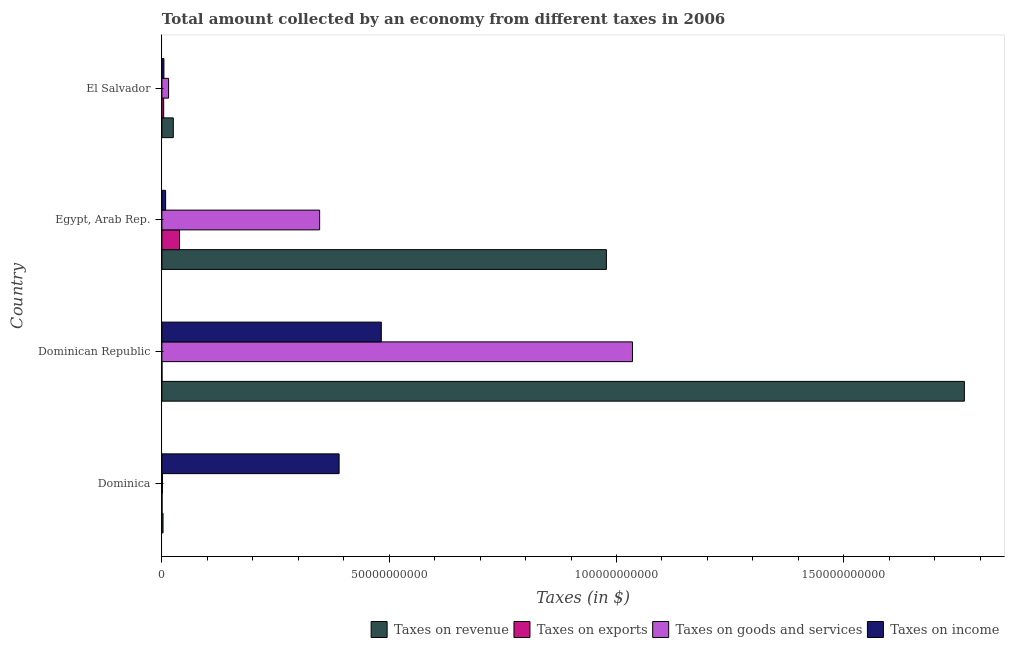How many different coloured bars are there?
Give a very brief answer. 4. How many groups of bars are there?
Offer a very short reply. 4. How many bars are there on the 4th tick from the top?
Ensure brevity in your answer.  4. What is the label of the 3rd group of bars from the top?
Provide a short and direct response. Dominican Republic. What is the amount collected as tax on revenue in Dominican Republic?
Provide a succinct answer. 1.77e+11. Across all countries, what is the maximum amount collected as tax on income?
Offer a terse response. 4.83e+1. Across all countries, what is the minimum amount collected as tax on exports?
Give a very brief answer. 7.49e+06. In which country was the amount collected as tax on exports maximum?
Make the answer very short. Egypt, Arab Rep. In which country was the amount collected as tax on goods minimum?
Give a very brief answer. Dominica. What is the total amount collected as tax on revenue in the graph?
Offer a very short reply. 2.77e+11. What is the difference between the amount collected as tax on income in Dominica and that in Egypt, Arab Rep.?
Provide a succinct answer. 3.82e+1. What is the difference between the amount collected as tax on income in Dominican Republic and the amount collected as tax on revenue in Egypt, Arab Rep.?
Your answer should be compact. -4.95e+1. What is the average amount collected as tax on goods per country?
Your response must be concise. 3.50e+1. What is the difference between the amount collected as tax on revenue and amount collected as tax on goods in Egypt, Arab Rep.?
Offer a terse response. 6.31e+1. In how many countries, is the amount collected as tax on goods greater than 160000000000 $?
Make the answer very short. 0. What is the ratio of the amount collected as tax on revenue in Dominica to that in Egypt, Arab Rep.?
Make the answer very short. 0. Is the amount collected as tax on revenue in Dominican Republic less than that in El Salvador?
Offer a very short reply. No. What is the difference between the highest and the second highest amount collected as tax on goods?
Offer a terse response. 6.88e+1. What is the difference between the highest and the lowest amount collected as tax on goods?
Give a very brief answer. 1.03e+11. In how many countries, is the amount collected as tax on revenue greater than the average amount collected as tax on revenue taken over all countries?
Offer a terse response. 2. Is the sum of the amount collected as tax on revenue in Egypt, Arab Rep. and El Salvador greater than the maximum amount collected as tax on income across all countries?
Your answer should be compact. Yes. What does the 2nd bar from the top in Egypt, Arab Rep. represents?
Your answer should be compact. Taxes on goods and services. What does the 4th bar from the bottom in Dominica represents?
Your answer should be compact. Taxes on income. How many bars are there?
Your response must be concise. 16. Are all the bars in the graph horizontal?
Your response must be concise. Yes. How many countries are there in the graph?
Ensure brevity in your answer.  4. Where does the legend appear in the graph?
Give a very brief answer. Bottom right. How many legend labels are there?
Provide a short and direct response. 4. What is the title of the graph?
Give a very brief answer. Total amount collected by an economy from different taxes in 2006. What is the label or title of the X-axis?
Keep it short and to the point. Taxes (in $). What is the Taxes (in $) of Taxes on revenue in Dominica?
Offer a terse response. 2.48e+08. What is the Taxes (in $) of Taxes on exports in Dominica?
Your answer should be compact. 2.40e+07. What is the Taxes (in $) in Taxes on goods and services in Dominica?
Offer a terse response. 1.23e+08. What is the Taxes (in $) in Taxes on income in Dominica?
Ensure brevity in your answer.  3.90e+1. What is the Taxes (in $) of Taxes on revenue in Dominican Republic?
Your response must be concise. 1.77e+11. What is the Taxes (in $) in Taxes on exports in Dominican Republic?
Provide a succinct answer. 7.49e+06. What is the Taxes (in $) of Taxes on goods and services in Dominican Republic?
Your response must be concise. 1.04e+11. What is the Taxes (in $) in Taxes on income in Dominican Republic?
Your answer should be very brief. 4.83e+1. What is the Taxes (in $) in Taxes on revenue in Egypt, Arab Rep.?
Keep it short and to the point. 9.78e+1. What is the Taxes (in $) of Taxes on exports in Egypt, Arab Rep.?
Offer a very short reply. 3.88e+09. What is the Taxes (in $) of Taxes on goods and services in Egypt, Arab Rep.?
Ensure brevity in your answer.  3.47e+1. What is the Taxes (in $) in Taxes on income in Egypt, Arab Rep.?
Your answer should be very brief. 8.16e+08. What is the Taxes (in $) in Taxes on revenue in El Salvador?
Keep it short and to the point. 2.51e+09. What is the Taxes (in $) in Taxes on exports in El Salvador?
Provide a short and direct response. 3.91e+08. What is the Taxes (in $) in Taxes on goods and services in El Salvador?
Your answer should be very brief. 1.47e+09. What is the Taxes (in $) of Taxes on income in El Salvador?
Keep it short and to the point. 4.46e+08. Across all countries, what is the maximum Taxes (in $) of Taxes on revenue?
Provide a succinct answer. 1.77e+11. Across all countries, what is the maximum Taxes (in $) in Taxes on exports?
Your answer should be compact. 3.88e+09. Across all countries, what is the maximum Taxes (in $) of Taxes on goods and services?
Keep it short and to the point. 1.04e+11. Across all countries, what is the maximum Taxes (in $) of Taxes on income?
Keep it short and to the point. 4.83e+1. Across all countries, what is the minimum Taxes (in $) of Taxes on revenue?
Provide a short and direct response. 2.48e+08. Across all countries, what is the minimum Taxes (in $) in Taxes on exports?
Make the answer very short. 7.49e+06. Across all countries, what is the minimum Taxes (in $) in Taxes on goods and services?
Offer a terse response. 1.23e+08. Across all countries, what is the minimum Taxes (in $) in Taxes on income?
Keep it short and to the point. 4.46e+08. What is the total Taxes (in $) in Taxes on revenue in the graph?
Offer a very short reply. 2.77e+11. What is the total Taxes (in $) of Taxes on exports in the graph?
Your answer should be very brief. 4.30e+09. What is the total Taxes (in $) in Taxes on goods and services in the graph?
Ensure brevity in your answer.  1.40e+11. What is the total Taxes (in $) of Taxes on income in the graph?
Make the answer very short. 8.85e+1. What is the difference between the Taxes (in $) in Taxes on revenue in Dominica and that in Dominican Republic?
Your answer should be very brief. -1.76e+11. What is the difference between the Taxes (in $) of Taxes on exports in Dominica and that in Dominican Republic?
Give a very brief answer. 1.65e+07. What is the difference between the Taxes (in $) in Taxes on goods and services in Dominica and that in Dominican Republic?
Your answer should be very brief. -1.03e+11. What is the difference between the Taxes (in $) of Taxes on income in Dominica and that in Dominican Republic?
Give a very brief answer. -9.29e+09. What is the difference between the Taxes (in $) in Taxes on revenue in Dominica and that in Egypt, Arab Rep.?
Keep it short and to the point. -9.75e+1. What is the difference between the Taxes (in $) in Taxes on exports in Dominica and that in Egypt, Arab Rep.?
Provide a succinct answer. -3.86e+09. What is the difference between the Taxes (in $) in Taxes on goods and services in Dominica and that in Egypt, Arab Rep.?
Your answer should be very brief. -3.46e+1. What is the difference between the Taxes (in $) in Taxes on income in Dominica and that in Egypt, Arab Rep.?
Offer a very short reply. 3.82e+1. What is the difference between the Taxes (in $) of Taxes on revenue in Dominica and that in El Salvador?
Your answer should be very brief. -2.26e+09. What is the difference between the Taxes (in $) of Taxes on exports in Dominica and that in El Salvador?
Give a very brief answer. -3.67e+08. What is the difference between the Taxes (in $) of Taxes on goods and services in Dominica and that in El Salvador?
Ensure brevity in your answer.  -1.35e+09. What is the difference between the Taxes (in $) of Taxes on income in Dominica and that in El Salvador?
Your answer should be compact. 3.85e+1. What is the difference between the Taxes (in $) in Taxes on revenue in Dominican Republic and that in Egypt, Arab Rep.?
Keep it short and to the point. 7.88e+1. What is the difference between the Taxes (in $) of Taxes on exports in Dominican Republic and that in Egypt, Arab Rep.?
Your answer should be compact. -3.87e+09. What is the difference between the Taxes (in $) in Taxes on goods and services in Dominican Republic and that in Egypt, Arab Rep.?
Your response must be concise. 6.88e+1. What is the difference between the Taxes (in $) in Taxes on income in Dominican Republic and that in Egypt, Arab Rep.?
Ensure brevity in your answer.  4.75e+1. What is the difference between the Taxes (in $) of Taxes on revenue in Dominican Republic and that in El Salvador?
Offer a very short reply. 1.74e+11. What is the difference between the Taxes (in $) in Taxes on exports in Dominican Republic and that in El Salvador?
Give a very brief answer. -3.84e+08. What is the difference between the Taxes (in $) of Taxes on goods and services in Dominican Republic and that in El Salvador?
Provide a short and direct response. 1.02e+11. What is the difference between the Taxes (in $) of Taxes on income in Dominican Republic and that in El Salvador?
Make the answer very short. 4.78e+1. What is the difference between the Taxes (in $) in Taxes on revenue in Egypt, Arab Rep. and that in El Salvador?
Your answer should be compact. 9.53e+1. What is the difference between the Taxes (in $) in Taxes on exports in Egypt, Arab Rep. and that in El Salvador?
Provide a short and direct response. 3.49e+09. What is the difference between the Taxes (in $) in Taxes on goods and services in Egypt, Arab Rep. and that in El Salvador?
Offer a very short reply. 3.32e+1. What is the difference between the Taxes (in $) of Taxes on income in Egypt, Arab Rep. and that in El Salvador?
Ensure brevity in your answer.  3.70e+08. What is the difference between the Taxes (in $) in Taxes on revenue in Dominica and the Taxes (in $) in Taxes on exports in Dominican Republic?
Make the answer very short. 2.40e+08. What is the difference between the Taxes (in $) in Taxes on revenue in Dominica and the Taxes (in $) in Taxes on goods and services in Dominican Republic?
Your response must be concise. -1.03e+11. What is the difference between the Taxes (in $) of Taxes on revenue in Dominica and the Taxes (in $) of Taxes on income in Dominican Republic?
Your answer should be compact. -4.80e+1. What is the difference between the Taxes (in $) in Taxes on exports in Dominica and the Taxes (in $) in Taxes on goods and services in Dominican Republic?
Provide a succinct answer. -1.03e+11. What is the difference between the Taxes (in $) of Taxes on exports in Dominica and the Taxes (in $) of Taxes on income in Dominican Republic?
Offer a terse response. -4.82e+1. What is the difference between the Taxes (in $) of Taxes on goods and services in Dominica and the Taxes (in $) of Taxes on income in Dominican Republic?
Ensure brevity in your answer.  -4.81e+1. What is the difference between the Taxes (in $) in Taxes on revenue in Dominica and the Taxes (in $) in Taxes on exports in Egypt, Arab Rep.?
Your answer should be very brief. -3.63e+09. What is the difference between the Taxes (in $) in Taxes on revenue in Dominica and the Taxes (in $) in Taxes on goods and services in Egypt, Arab Rep.?
Provide a succinct answer. -3.45e+1. What is the difference between the Taxes (in $) of Taxes on revenue in Dominica and the Taxes (in $) of Taxes on income in Egypt, Arab Rep.?
Provide a succinct answer. -5.68e+08. What is the difference between the Taxes (in $) in Taxes on exports in Dominica and the Taxes (in $) in Taxes on goods and services in Egypt, Arab Rep.?
Your answer should be very brief. -3.47e+1. What is the difference between the Taxes (in $) in Taxes on exports in Dominica and the Taxes (in $) in Taxes on income in Egypt, Arab Rep.?
Keep it short and to the point. -7.92e+08. What is the difference between the Taxes (in $) in Taxes on goods and services in Dominica and the Taxes (in $) in Taxes on income in Egypt, Arab Rep.?
Ensure brevity in your answer.  -6.93e+08. What is the difference between the Taxes (in $) in Taxes on revenue in Dominica and the Taxes (in $) in Taxes on exports in El Salvador?
Provide a succinct answer. -1.44e+08. What is the difference between the Taxes (in $) in Taxes on revenue in Dominica and the Taxes (in $) in Taxes on goods and services in El Salvador?
Make the answer very short. -1.22e+09. What is the difference between the Taxes (in $) of Taxes on revenue in Dominica and the Taxes (in $) of Taxes on income in El Salvador?
Your answer should be very brief. -1.98e+08. What is the difference between the Taxes (in $) in Taxes on exports in Dominica and the Taxes (in $) in Taxes on goods and services in El Salvador?
Offer a terse response. -1.45e+09. What is the difference between the Taxes (in $) in Taxes on exports in Dominica and the Taxes (in $) in Taxes on income in El Salvador?
Provide a succinct answer. -4.22e+08. What is the difference between the Taxes (in $) of Taxes on goods and services in Dominica and the Taxes (in $) of Taxes on income in El Salvador?
Keep it short and to the point. -3.22e+08. What is the difference between the Taxes (in $) of Taxes on revenue in Dominican Republic and the Taxes (in $) of Taxes on exports in Egypt, Arab Rep.?
Offer a terse response. 1.73e+11. What is the difference between the Taxes (in $) in Taxes on revenue in Dominican Republic and the Taxes (in $) in Taxes on goods and services in Egypt, Arab Rep.?
Offer a terse response. 1.42e+11. What is the difference between the Taxes (in $) in Taxes on revenue in Dominican Republic and the Taxes (in $) in Taxes on income in Egypt, Arab Rep.?
Keep it short and to the point. 1.76e+11. What is the difference between the Taxes (in $) in Taxes on exports in Dominican Republic and the Taxes (in $) in Taxes on goods and services in Egypt, Arab Rep.?
Make the answer very short. -3.47e+1. What is the difference between the Taxes (in $) in Taxes on exports in Dominican Republic and the Taxes (in $) in Taxes on income in Egypt, Arab Rep.?
Your answer should be very brief. -8.08e+08. What is the difference between the Taxes (in $) in Taxes on goods and services in Dominican Republic and the Taxes (in $) in Taxes on income in Egypt, Arab Rep.?
Offer a terse response. 1.03e+11. What is the difference between the Taxes (in $) of Taxes on revenue in Dominican Republic and the Taxes (in $) of Taxes on exports in El Salvador?
Provide a short and direct response. 1.76e+11. What is the difference between the Taxes (in $) of Taxes on revenue in Dominican Republic and the Taxes (in $) of Taxes on goods and services in El Salvador?
Make the answer very short. 1.75e+11. What is the difference between the Taxes (in $) of Taxes on revenue in Dominican Republic and the Taxes (in $) of Taxes on income in El Salvador?
Your answer should be very brief. 1.76e+11. What is the difference between the Taxes (in $) in Taxes on exports in Dominican Republic and the Taxes (in $) in Taxes on goods and services in El Salvador?
Keep it short and to the point. -1.46e+09. What is the difference between the Taxes (in $) in Taxes on exports in Dominican Republic and the Taxes (in $) in Taxes on income in El Salvador?
Provide a succinct answer. -4.38e+08. What is the difference between the Taxes (in $) of Taxes on goods and services in Dominican Republic and the Taxes (in $) of Taxes on income in El Salvador?
Your answer should be very brief. 1.03e+11. What is the difference between the Taxes (in $) of Taxes on revenue in Egypt, Arab Rep. and the Taxes (in $) of Taxes on exports in El Salvador?
Offer a very short reply. 9.74e+1. What is the difference between the Taxes (in $) in Taxes on revenue in Egypt, Arab Rep. and the Taxes (in $) in Taxes on goods and services in El Salvador?
Your answer should be compact. 9.63e+1. What is the difference between the Taxes (in $) in Taxes on revenue in Egypt, Arab Rep. and the Taxes (in $) in Taxes on income in El Salvador?
Ensure brevity in your answer.  9.73e+1. What is the difference between the Taxes (in $) in Taxes on exports in Egypt, Arab Rep. and the Taxes (in $) in Taxes on goods and services in El Salvador?
Keep it short and to the point. 2.41e+09. What is the difference between the Taxes (in $) in Taxes on exports in Egypt, Arab Rep. and the Taxes (in $) in Taxes on income in El Salvador?
Offer a very short reply. 3.43e+09. What is the difference between the Taxes (in $) in Taxes on goods and services in Egypt, Arab Rep. and the Taxes (in $) in Taxes on income in El Salvador?
Provide a short and direct response. 3.43e+1. What is the average Taxes (in $) in Taxes on revenue per country?
Your answer should be compact. 6.93e+1. What is the average Taxes (in $) of Taxes on exports per country?
Provide a short and direct response. 1.08e+09. What is the average Taxes (in $) in Taxes on goods and services per country?
Provide a short and direct response. 3.50e+1. What is the average Taxes (in $) in Taxes on income per country?
Give a very brief answer. 2.21e+1. What is the difference between the Taxes (in $) in Taxes on revenue and Taxes (in $) in Taxes on exports in Dominica?
Keep it short and to the point. 2.24e+08. What is the difference between the Taxes (in $) of Taxes on revenue and Taxes (in $) of Taxes on goods and services in Dominica?
Ensure brevity in your answer.  1.25e+08. What is the difference between the Taxes (in $) of Taxes on revenue and Taxes (in $) of Taxes on income in Dominica?
Offer a terse response. -3.87e+1. What is the difference between the Taxes (in $) of Taxes on exports and Taxes (in $) of Taxes on goods and services in Dominica?
Make the answer very short. -9.92e+07. What is the difference between the Taxes (in $) of Taxes on exports and Taxes (in $) of Taxes on income in Dominica?
Your answer should be compact. -3.90e+1. What is the difference between the Taxes (in $) in Taxes on goods and services and Taxes (in $) in Taxes on income in Dominica?
Provide a short and direct response. -3.89e+1. What is the difference between the Taxes (in $) of Taxes on revenue and Taxes (in $) of Taxes on exports in Dominican Republic?
Your response must be concise. 1.77e+11. What is the difference between the Taxes (in $) of Taxes on revenue and Taxes (in $) of Taxes on goods and services in Dominican Republic?
Your response must be concise. 7.30e+1. What is the difference between the Taxes (in $) of Taxes on revenue and Taxes (in $) of Taxes on income in Dominican Republic?
Your response must be concise. 1.28e+11. What is the difference between the Taxes (in $) of Taxes on exports and Taxes (in $) of Taxes on goods and services in Dominican Republic?
Provide a succinct answer. -1.04e+11. What is the difference between the Taxes (in $) of Taxes on exports and Taxes (in $) of Taxes on income in Dominican Republic?
Make the answer very short. -4.83e+1. What is the difference between the Taxes (in $) in Taxes on goods and services and Taxes (in $) in Taxes on income in Dominican Republic?
Offer a very short reply. 5.53e+1. What is the difference between the Taxes (in $) in Taxes on revenue and Taxes (in $) in Taxes on exports in Egypt, Arab Rep.?
Your answer should be compact. 9.39e+1. What is the difference between the Taxes (in $) of Taxes on revenue and Taxes (in $) of Taxes on goods and services in Egypt, Arab Rep.?
Keep it short and to the point. 6.31e+1. What is the difference between the Taxes (in $) of Taxes on revenue and Taxes (in $) of Taxes on income in Egypt, Arab Rep.?
Provide a short and direct response. 9.70e+1. What is the difference between the Taxes (in $) in Taxes on exports and Taxes (in $) in Taxes on goods and services in Egypt, Arab Rep.?
Provide a succinct answer. -3.08e+1. What is the difference between the Taxes (in $) in Taxes on exports and Taxes (in $) in Taxes on income in Egypt, Arab Rep.?
Ensure brevity in your answer.  3.06e+09. What is the difference between the Taxes (in $) of Taxes on goods and services and Taxes (in $) of Taxes on income in Egypt, Arab Rep.?
Provide a succinct answer. 3.39e+1. What is the difference between the Taxes (in $) in Taxes on revenue and Taxes (in $) in Taxes on exports in El Salvador?
Provide a succinct answer. 2.12e+09. What is the difference between the Taxes (in $) of Taxes on revenue and Taxes (in $) of Taxes on goods and services in El Salvador?
Your answer should be very brief. 1.04e+09. What is the difference between the Taxes (in $) in Taxes on revenue and Taxes (in $) in Taxes on income in El Salvador?
Your response must be concise. 2.06e+09. What is the difference between the Taxes (in $) of Taxes on exports and Taxes (in $) of Taxes on goods and services in El Salvador?
Give a very brief answer. -1.08e+09. What is the difference between the Taxes (in $) of Taxes on exports and Taxes (in $) of Taxes on income in El Salvador?
Your answer should be compact. -5.40e+07. What is the difference between the Taxes (in $) in Taxes on goods and services and Taxes (in $) in Taxes on income in El Salvador?
Keep it short and to the point. 1.03e+09. What is the ratio of the Taxes (in $) of Taxes on revenue in Dominica to that in Dominican Republic?
Make the answer very short. 0. What is the ratio of the Taxes (in $) of Taxes on exports in Dominica to that in Dominican Republic?
Your response must be concise. 3.2. What is the ratio of the Taxes (in $) of Taxes on goods and services in Dominica to that in Dominican Republic?
Make the answer very short. 0. What is the ratio of the Taxes (in $) of Taxes on income in Dominica to that in Dominican Republic?
Offer a very short reply. 0.81. What is the ratio of the Taxes (in $) in Taxes on revenue in Dominica to that in Egypt, Arab Rep.?
Keep it short and to the point. 0. What is the ratio of the Taxes (in $) of Taxes on exports in Dominica to that in Egypt, Arab Rep.?
Make the answer very short. 0.01. What is the ratio of the Taxes (in $) of Taxes on goods and services in Dominica to that in Egypt, Arab Rep.?
Make the answer very short. 0. What is the ratio of the Taxes (in $) in Taxes on income in Dominica to that in Egypt, Arab Rep.?
Keep it short and to the point. 47.78. What is the ratio of the Taxes (in $) in Taxes on revenue in Dominica to that in El Salvador?
Your response must be concise. 0.1. What is the ratio of the Taxes (in $) in Taxes on exports in Dominica to that in El Salvador?
Your response must be concise. 0.06. What is the ratio of the Taxes (in $) in Taxes on goods and services in Dominica to that in El Salvador?
Offer a terse response. 0.08. What is the ratio of the Taxes (in $) of Taxes on income in Dominica to that in El Salvador?
Make the answer very short. 87.5. What is the ratio of the Taxes (in $) of Taxes on revenue in Dominican Republic to that in Egypt, Arab Rep.?
Ensure brevity in your answer.  1.81. What is the ratio of the Taxes (in $) of Taxes on exports in Dominican Republic to that in Egypt, Arab Rep.?
Ensure brevity in your answer.  0. What is the ratio of the Taxes (in $) in Taxes on goods and services in Dominican Republic to that in Egypt, Arab Rep.?
Offer a very short reply. 2.98. What is the ratio of the Taxes (in $) in Taxes on income in Dominican Republic to that in Egypt, Arab Rep.?
Your answer should be compact. 59.16. What is the ratio of the Taxes (in $) of Taxes on revenue in Dominican Republic to that in El Salvador?
Your answer should be compact. 70.41. What is the ratio of the Taxes (in $) in Taxes on exports in Dominican Republic to that in El Salvador?
Your answer should be compact. 0.02. What is the ratio of the Taxes (in $) in Taxes on goods and services in Dominican Republic to that in El Salvador?
Your answer should be very brief. 70.32. What is the ratio of the Taxes (in $) in Taxes on income in Dominican Republic to that in El Salvador?
Make the answer very short. 108.35. What is the ratio of the Taxes (in $) of Taxes on revenue in Egypt, Arab Rep. to that in El Salvador?
Make the answer very short. 39. What is the ratio of the Taxes (in $) in Taxes on exports in Egypt, Arab Rep. to that in El Salvador?
Provide a succinct answer. 9.91. What is the ratio of the Taxes (in $) in Taxes on goods and services in Egypt, Arab Rep. to that in El Salvador?
Keep it short and to the point. 23.57. What is the ratio of the Taxes (in $) of Taxes on income in Egypt, Arab Rep. to that in El Salvador?
Your answer should be compact. 1.83. What is the difference between the highest and the second highest Taxes (in $) of Taxes on revenue?
Keep it short and to the point. 7.88e+1. What is the difference between the highest and the second highest Taxes (in $) in Taxes on exports?
Give a very brief answer. 3.49e+09. What is the difference between the highest and the second highest Taxes (in $) of Taxes on goods and services?
Provide a succinct answer. 6.88e+1. What is the difference between the highest and the second highest Taxes (in $) in Taxes on income?
Ensure brevity in your answer.  9.29e+09. What is the difference between the highest and the lowest Taxes (in $) in Taxes on revenue?
Keep it short and to the point. 1.76e+11. What is the difference between the highest and the lowest Taxes (in $) in Taxes on exports?
Make the answer very short. 3.87e+09. What is the difference between the highest and the lowest Taxes (in $) of Taxes on goods and services?
Ensure brevity in your answer.  1.03e+11. What is the difference between the highest and the lowest Taxes (in $) in Taxes on income?
Make the answer very short. 4.78e+1. 